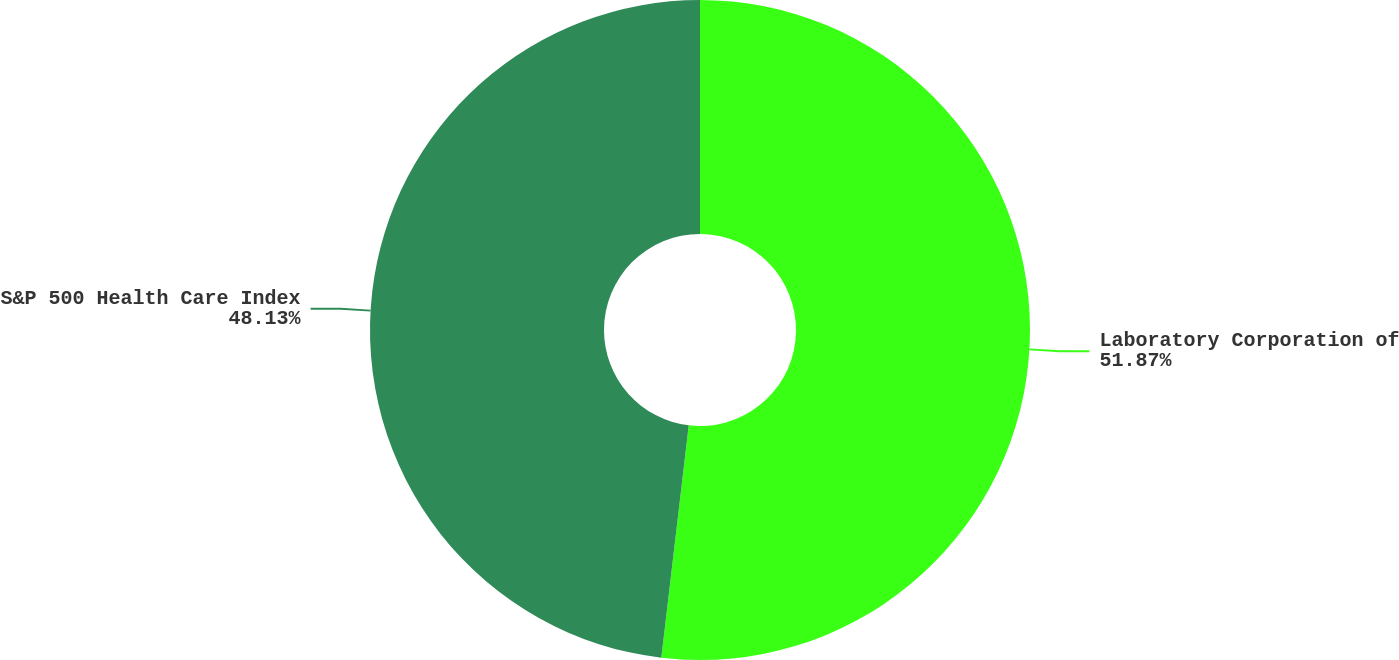Convert chart. <chart><loc_0><loc_0><loc_500><loc_500><pie_chart><fcel>Laboratory Corporation of<fcel>S&P 500 Health Care Index<nl><fcel>51.87%<fcel>48.13%<nl></chart> 